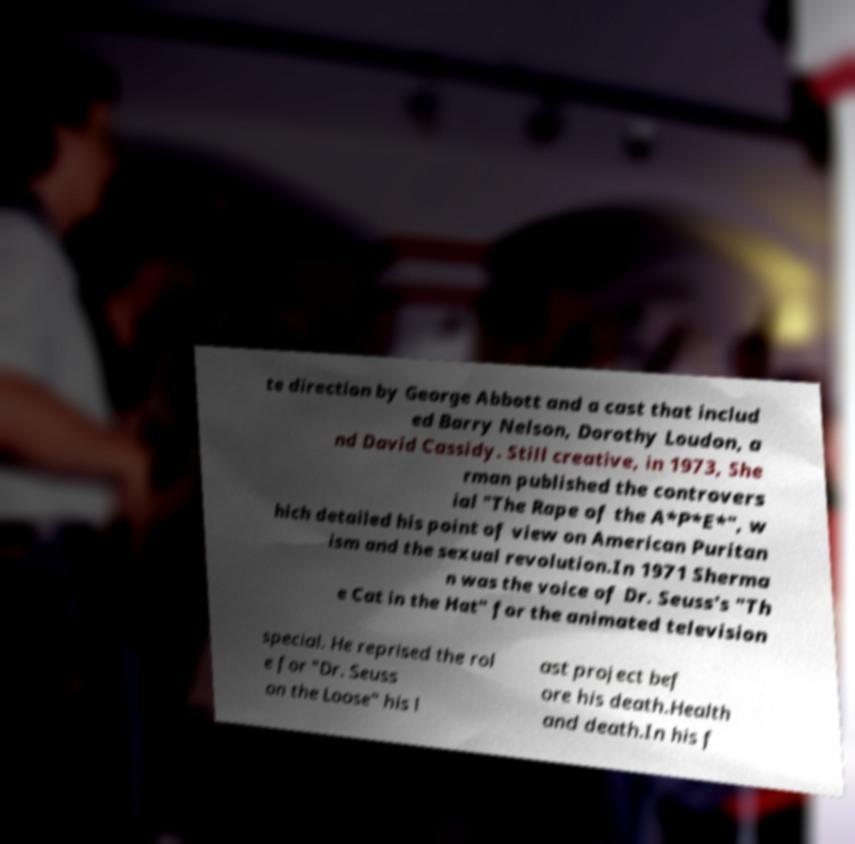Please identify and transcribe the text found in this image. te direction by George Abbott and a cast that includ ed Barry Nelson, Dorothy Loudon, a nd David Cassidy. Still creative, in 1973, She rman published the controvers ial "The Rape of the A*P*E*", w hich detailed his point of view on American Puritan ism and the sexual revolution.In 1971 Sherma n was the voice of Dr. Seuss's "Th e Cat in the Hat" for the animated television special. He reprised the rol e for "Dr. Seuss on the Loose" his l ast project bef ore his death.Health and death.In his f 